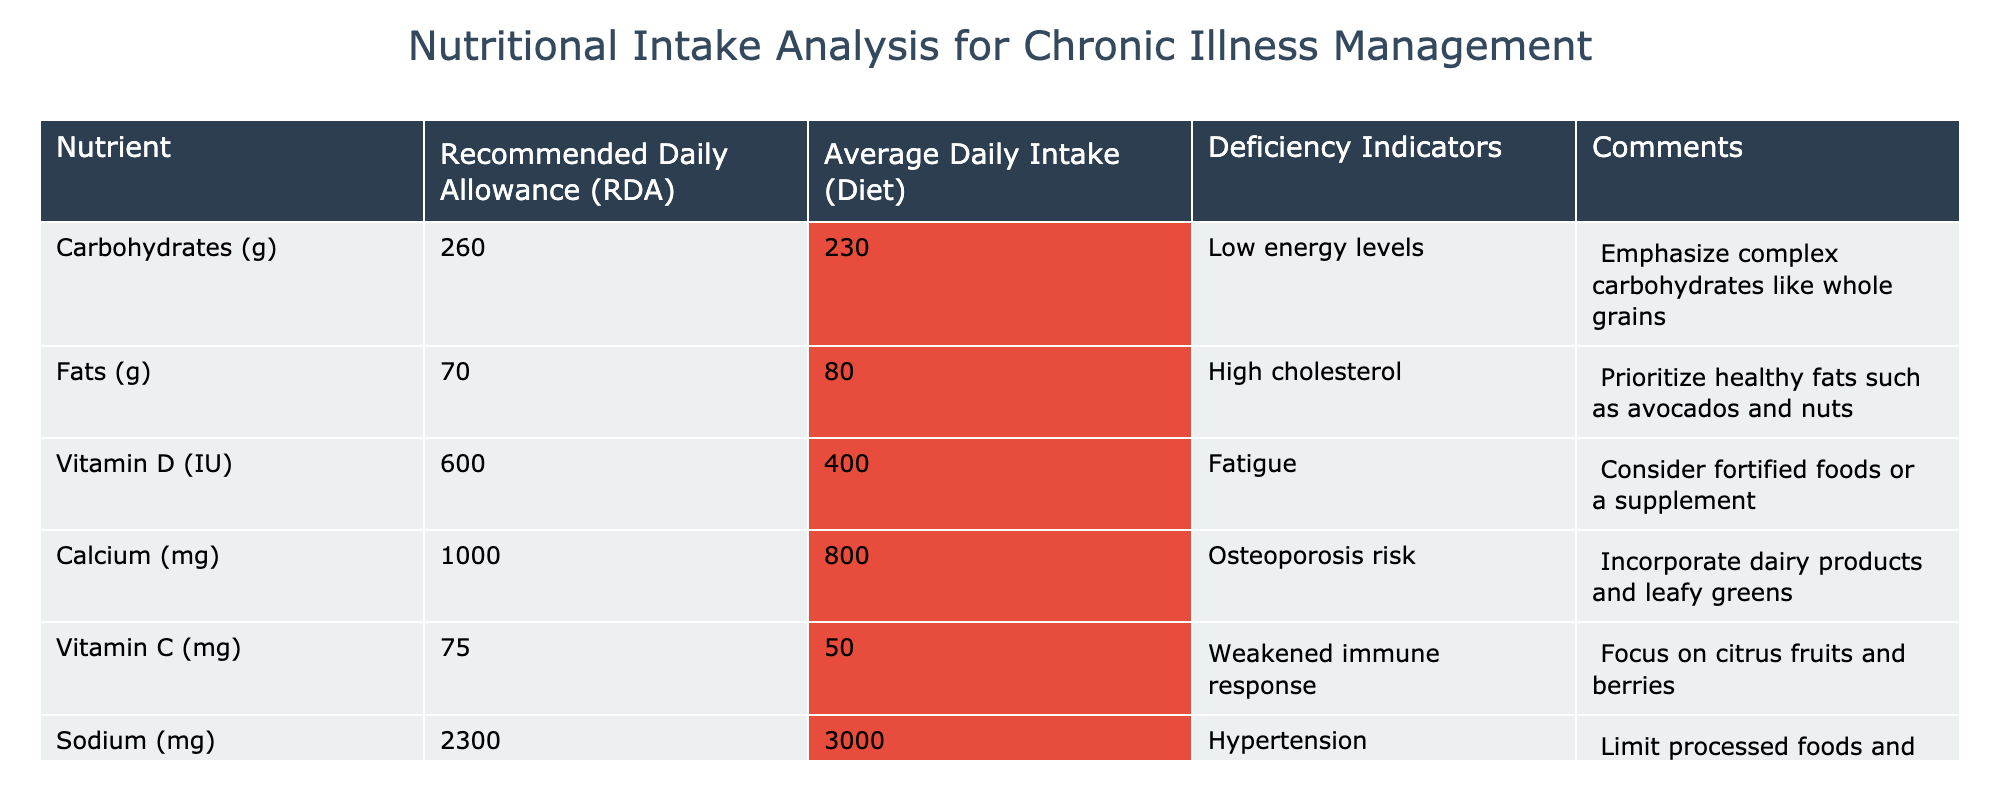What is the average daily intake of carbohydrates? The table states the average daily intake of carbohydrates is 230 grams.
Answer: 230 grams How much calcium is recommended daily? According to the table, the Recommended Daily Allowance for calcium is 1000 mg.
Answer: 1000 mg Is the average daily intake of vitamin C below the recommended level? The average daily intake of vitamin C is 50 mg, while the recommended level is 75 mg, indicating it is indeed below the recommended level.
Answer: Yes What is the difference between the Recommended Daily Allowance and the average daily intake for fats? The Recommended Daily Allowance for fats is 70 grams and the average daily intake is 80 grams, so the difference is 80 - 70 = 10 grams.
Answer: 10 grams Which nutrient has the highest average daily intake compared to its Recommended Daily Allowance? Fats have an average daily intake of 80 grams, which exceeds the Recommended Daily Allowance of 70 grams by 10 grams.
Answer: Fats What is the total shortfall in daily intake of vitamin D and calcium combined? The shortfall for vitamin D is 600 - 400 = 200 IU, and for calcium it is 1000 - 800 = 200 mg. To find the total shortfall, we add these two amounts: 200 + 200 = 400 (considering different units: this comparison reflects the need for the nutrients).
Answer: 400 (in terms of overall deficiency, differing units) Is there any nutrient listed that exceeds the recommended intake? Yes, sodium is given as 3000 mg, exceeding the recommended intake of 2300 mg.
Answer: Yes What recommendations are provided for addressing the deficiency in vitamin D? The comments section specifies considering fortified foods or a supplement to address the deficiency in vitamin D.
Answer: Fortified foods or a supplement What lifestyle change is suggested to help manage high cholesterol based on the fats intake? The comments suggest prioritizing healthy fats such as avocados and nuts, implying a lifestyle change towards healthier fat sources.
Answer: Prioritize healthy fats Which deficiency indicator relates to carbohydrates, and how can it be addressed? The deficiency indicator for carbohydrates is "low energy levels," and it suggests emphasizing complex carbohydrates like whole grains to address this.
Answer: Emphasize complex carbohydrates 